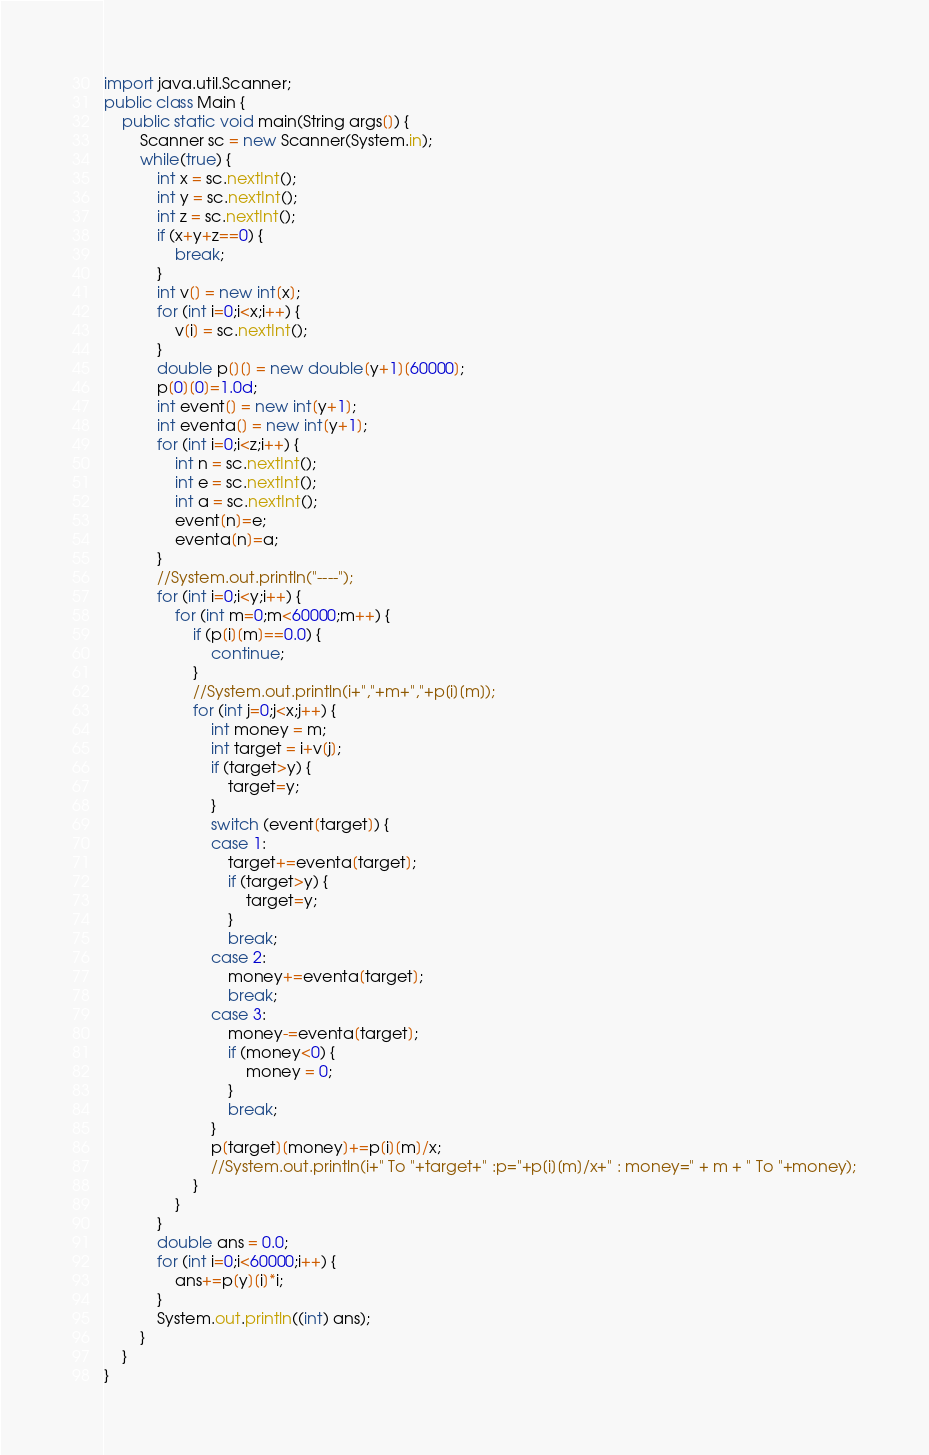<code> <loc_0><loc_0><loc_500><loc_500><_Java_>import java.util.Scanner;
public class Main {
	public static void main(String args[]) {
		Scanner sc = new Scanner(System.in);
		while(true) {
			int x = sc.nextInt();
			int y = sc.nextInt();
			int z = sc.nextInt();
			if (x+y+z==0) {
				break;
			}
			int v[] = new int[x];
			for (int i=0;i<x;i++) {
				v[i] = sc.nextInt();
			}
			double p[][] = new double[y+1][60000];
			p[0][0]=1.0d;
			int event[] = new int[y+1];
			int eventa[] = new int[y+1];
			for (int i=0;i<z;i++) {
				int n = sc.nextInt();
				int e = sc.nextInt();
				int a = sc.nextInt();
				event[n]=e;
				eventa[n]=a;
			}
			//System.out.println("----");
			for (int i=0;i<y;i++) {
				for (int m=0;m<60000;m++) {
					if (p[i][m]==0.0) {
						continue;
					}
					//System.out.println(i+","+m+","+p[i][m]);
					for (int j=0;j<x;j++) {
						int money = m;
						int target = i+v[j];
						if (target>y) {
							target=y;
						}
						switch (event[target]) {
						case 1:
							target+=eventa[target];
							if (target>y) {
								target=y;
							}
							break;
						case 2:
							money+=eventa[target];
							break;
						case 3:
							money-=eventa[target];
							if (money<0) {
								money = 0;
							}
							break;
						}
						p[target][money]+=p[i][m]/x;
						//System.out.println(i+" To "+target+" :p="+p[i][m]/x+" : money=" + m + " To "+money);
					}
				}
			}
			double ans = 0.0;
			for (int i=0;i<60000;i++) {
				ans+=p[y][i]*i;
			}
			System.out.println((int) ans);
		}
	}
}</code> 